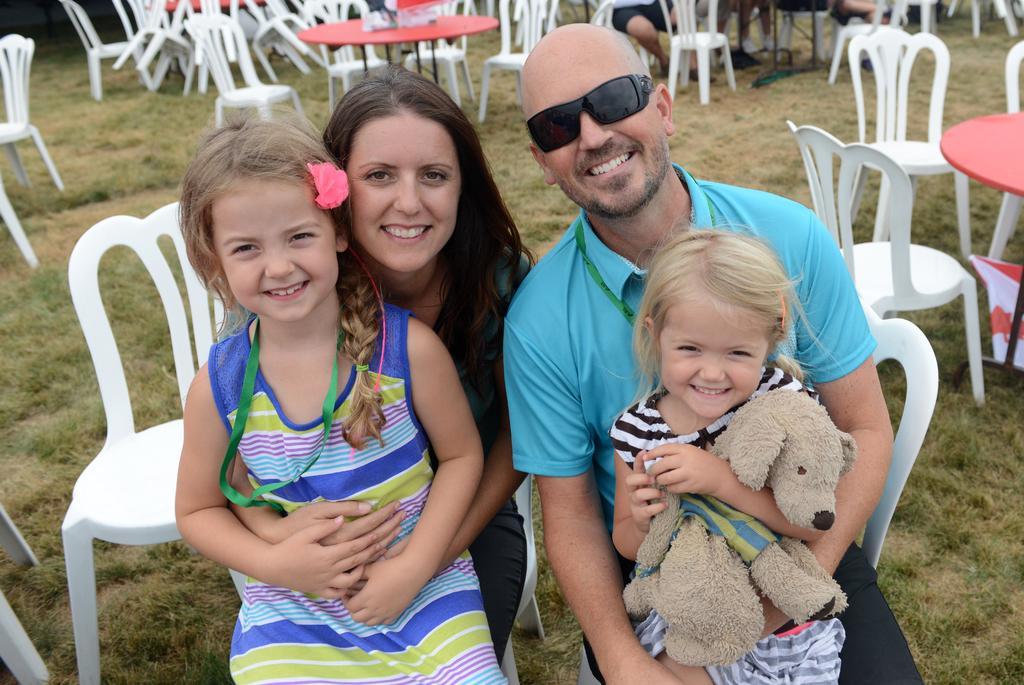Please provide a concise description of this image. In this image we can see the persons sitting on the chairs and holding a child. We can see a doll and there are tables, chairs and few objects. 